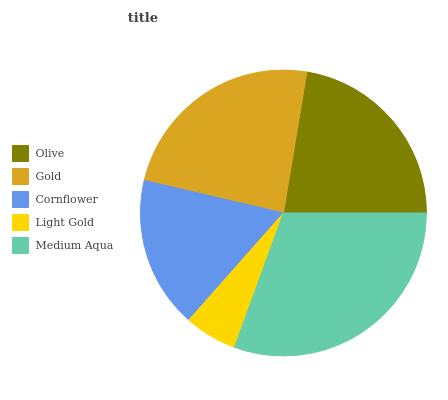Is Light Gold the minimum?
Answer yes or no. Yes. Is Medium Aqua the maximum?
Answer yes or no. Yes. Is Gold the minimum?
Answer yes or no. No. Is Gold the maximum?
Answer yes or no. No. Is Gold greater than Olive?
Answer yes or no. Yes. Is Olive less than Gold?
Answer yes or no. Yes. Is Olive greater than Gold?
Answer yes or no. No. Is Gold less than Olive?
Answer yes or no. No. Is Olive the high median?
Answer yes or no. Yes. Is Olive the low median?
Answer yes or no. Yes. Is Cornflower the high median?
Answer yes or no. No. Is Light Gold the low median?
Answer yes or no. No. 